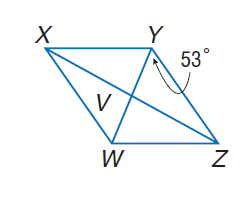Answer the mathemtical geometry problem and directly provide the correct option letter.
Question: Use rhombus X Y Z W with m \angle W Y Z = 53, V W = 3, X V = 2 a - 2, and Z V = \frac { 5 a + 1 } { 4 }. Find m \angle Y Z V.
Choices: A: 18 B: 37 C: 53 D: 90 B 